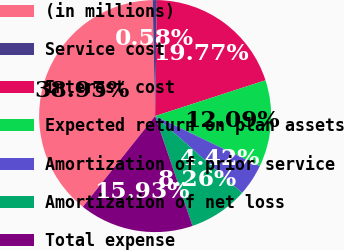Convert chart to OTSL. <chart><loc_0><loc_0><loc_500><loc_500><pie_chart><fcel>(in millions)<fcel>Service cost<fcel>Interest cost<fcel>Expected return on plan assets<fcel>Amortization of prior service<fcel>Amortization of net loss<fcel>Total expense<nl><fcel>38.95%<fcel>0.58%<fcel>19.77%<fcel>12.09%<fcel>4.42%<fcel>8.26%<fcel>15.93%<nl></chart> 